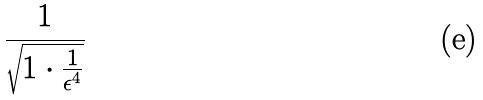Convert formula to latex. <formula><loc_0><loc_0><loc_500><loc_500>\frac { 1 } { \sqrt { 1 \cdot \frac { 1 } { \epsilon ^ { 4 } } } }</formula> 